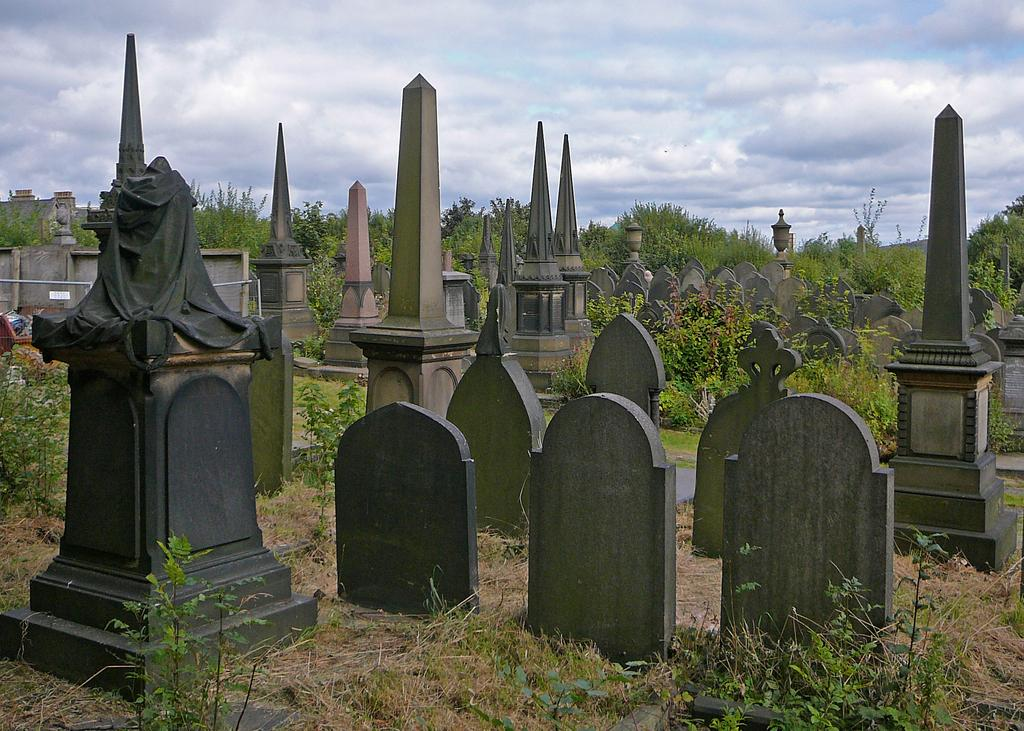What type of location is depicted in the image? The image depicts a cemetery. What can be found in the cemetery? There are many graves in the cemetery. What type of vegetation is present in the cemetery? There are grasses and trees in the cemetery. What is visible in the background of the image? The sky is visible in the background of the image. What can be observed in the sky? Clouds are present in the sky. What direction is the mother walking in the image? There is no mother present in the image; it depicts a cemetery with graves, grasses, trees, and a sky with clouds. What is the heart rate of the person buried in the image? There is no person buried in the image; it is a photograph of a cemetery with graves, grasses, trees, and a sky with clouds. 